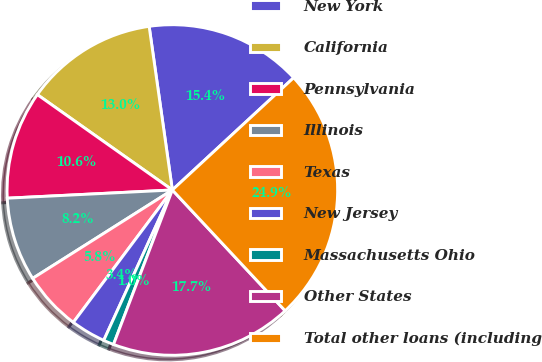<chart> <loc_0><loc_0><loc_500><loc_500><pie_chart><fcel>New York<fcel>California<fcel>Pennsylvania<fcel>Illinois<fcel>Texas<fcel>New Jersey<fcel>Massachusetts Ohio<fcel>Other States<fcel>Total other loans (including<nl><fcel>15.36%<fcel>12.97%<fcel>10.58%<fcel>8.19%<fcel>5.8%<fcel>3.41%<fcel>1.02%<fcel>17.75%<fcel>24.93%<nl></chart> 